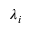<formula> <loc_0><loc_0><loc_500><loc_500>\lambda _ { i }</formula> 